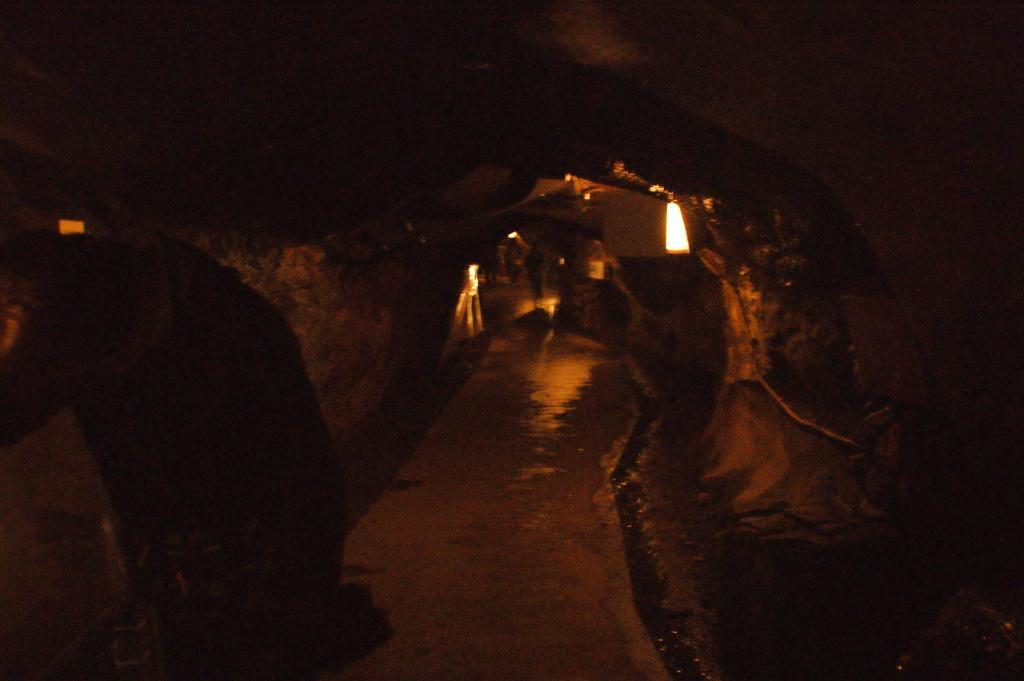Please provide a concise description of this image. In this image, we can see the inside view of a cave. We can see the ground. We can also see some objects and lights. 